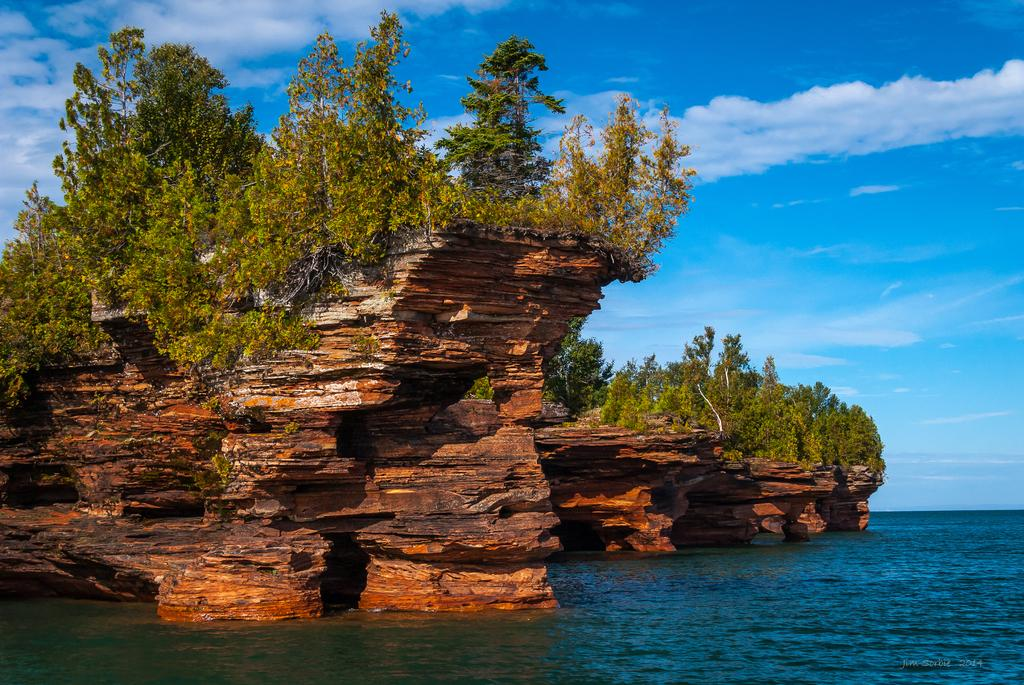What is the primary element visible in the image? There is water in the image. What can be seen on the left side of the image? There are trees and mountains on the left side of the image. What is visible in the sky in the image? There are clouds in the sky. Where is the downtown area in the image? There is no downtown area present in the image. What type of cannon can be seen firing in the image? There is no cannon present in the image. 